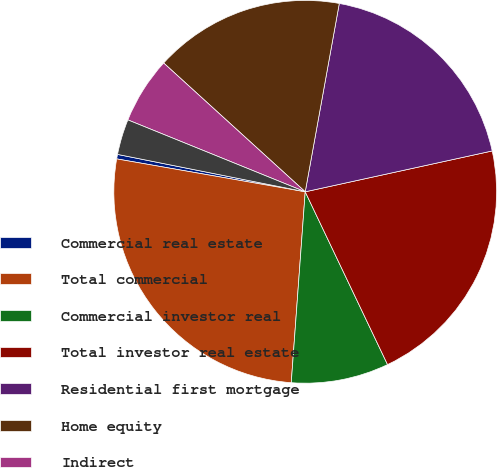<chart> <loc_0><loc_0><loc_500><loc_500><pie_chart><fcel>Commercial real estate<fcel>Total commercial<fcel>Commercial investor real<fcel>Total investor real estate<fcel>Residential first mortgage<fcel>Home equity<fcel>Indirect<fcel>Other consumer<nl><fcel>0.38%<fcel>26.59%<fcel>8.24%<fcel>21.35%<fcel>18.73%<fcel>16.1%<fcel>5.62%<fcel>3.0%<nl></chart> 